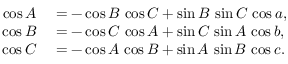<formula> <loc_0><loc_0><loc_500><loc_500>\begin{array} { r l } { \cos A } & = - \cos B \, \cos C + \sin B \, \sin C \, \cos a , } \\ { \cos B } & = - \cos C \, \cos A + \sin C \, \sin A \, \cos b , } \\ { \cos C } & = - \cos A \, \cos B + \sin A \, \sin B \, \cos c . } \end{array}</formula> 